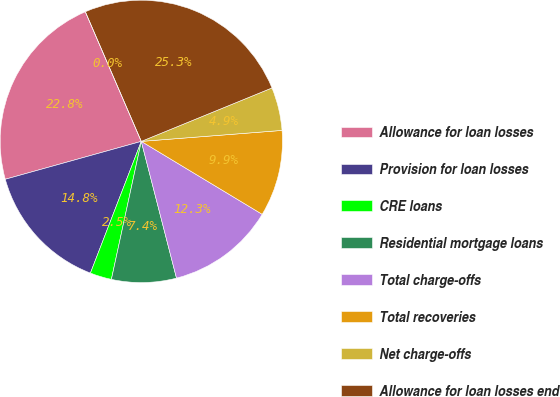<chart> <loc_0><loc_0><loc_500><loc_500><pie_chart><fcel>Allowance for loan losses<fcel>Provision for loan losses<fcel>CRE loans<fcel>Residential mortgage loans<fcel>Total charge-offs<fcel>Total recoveries<fcel>Net charge-offs<fcel>Allowance for loan losses end<fcel>Allowance for loan losses to<nl><fcel>22.84%<fcel>14.81%<fcel>2.47%<fcel>7.41%<fcel>12.35%<fcel>9.88%<fcel>4.94%<fcel>25.31%<fcel>0.0%<nl></chart> 